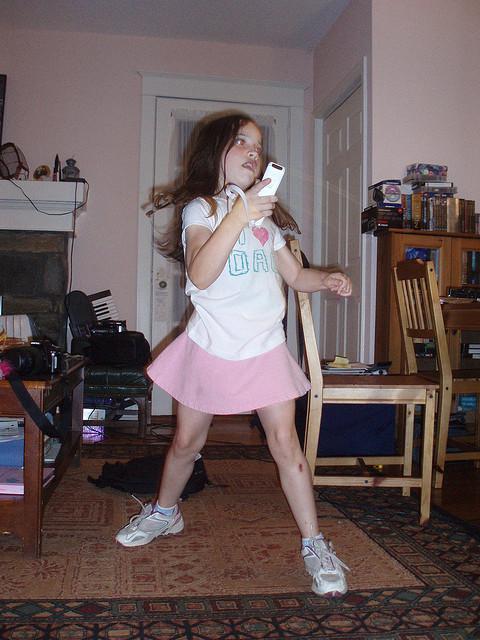How many chairs are in the picture?
Give a very brief answer. 3. How many forks are on the plate?
Give a very brief answer. 0. 